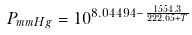<formula> <loc_0><loc_0><loc_500><loc_500>P _ { m m H g } = 1 0 ^ { 8 . 0 4 4 9 4 - { \frac { 1 5 5 4 . 3 } { 2 2 2 . 6 5 + T } } }</formula> 